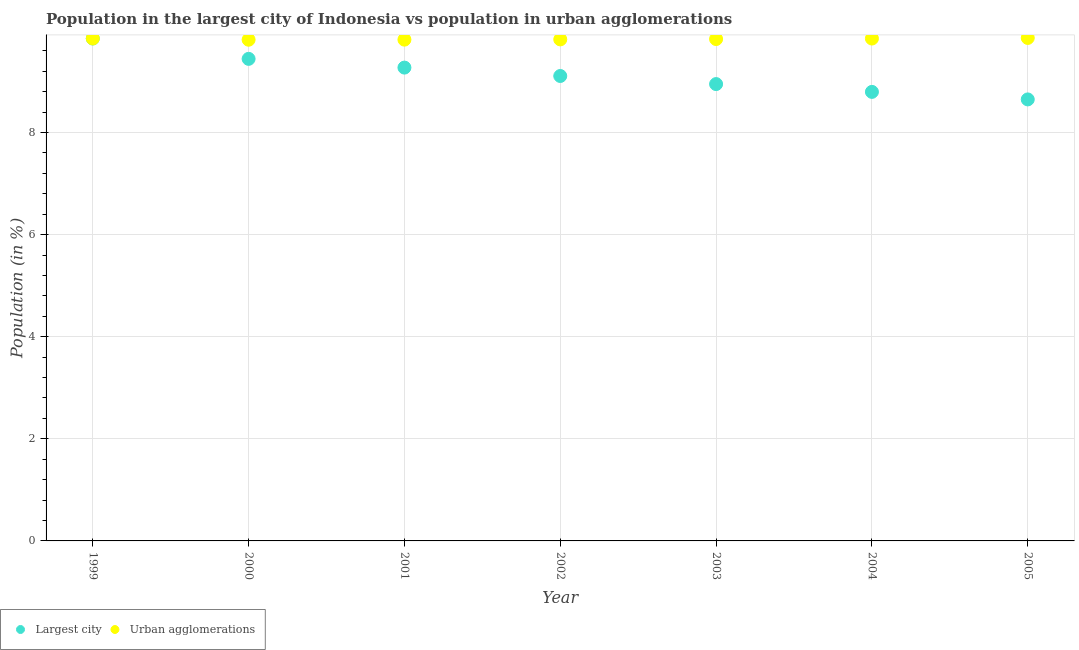What is the population in the largest city in 2003?
Provide a succinct answer. 8.95. Across all years, what is the maximum population in the largest city?
Keep it short and to the point. 9.84. Across all years, what is the minimum population in the largest city?
Keep it short and to the point. 8.65. In which year was the population in the largest city maximum?
Your response must be concise. 1999. In which year was the population in urban agglomerations minimum?
Ensure brevity in your answer.  2000. What is the total population in the largest city in the graph?
Your answer should be very brief. 64.05. What is the difference between the population in urban agglomerations in 1999 and that in 2002?
Provide a succinct answer. 0.02. What is the difference between the population in the largest city in 1999 and the population in urban agglomerations in 2004?
Provide a succinct answer. 0. What is the average population in urban agglomerations per year?
Your answer should be very brief. 9.83. In the year 2005, what is the difference between the population in the largest city and population in urban agglomerations?
Provide a short and direct response. -1.2. What is the ratio of the population in urban agglomerations in 2003 to that in 2004?
Ensure brevity in your answer.  1. Is the population in the largest city in 1999 less than that in 2003?
Your response must be concise. No. Is the difference between the population in urban agglomerations in 2000 and 2002 greater than the difference between the population in the largest city in 2000 and 2002?
Your response must be concise. No. What is the difference between the highest and the second highest population in urban agglomerations?
Ensure brevity in your answer.  0.01. What is the difference between the highest and the lowest population in the largest city?
Ensure brevity in your answer.  1.19. Is the population in the largest city strictly greater than the population in urban agglomerations over the years?
Offer a terse response. No. Is the population in the largest city strictly less than the population in urban agglomerations over the years?
Your answer should be compact. Yes. How many dotlines are there?
Your response must be concise. 2. How many years are there in the graph?
Ensure brevity in your answer.  7. Are the values on the major ticks of Y-axis written in scientific E-notation?
Offer a very short reply. No. How are the legend labels stacked?
Give a very brief answer. Horizontal. What is the title of the graph?
Ensure brevity in your answer.  Population in the largest city of Indonesia vs population in urban agglomerations. Does "% of gross capital formation" appear as one of the legend labels in the graph?
Your answer should be compact. No. What is the label or title of the X-axis?
Your response must be concise. Year. What is the Population (in %) of Largest city in 1999?
Make the answer very short. 9.84. What is the Population (in %) of Urban agglomerations in 1999?
Keep it short and to the point. 9.84. What is the Population (in %) of Largest city in 2000?
Give a very brief answer. 9.44. What is the Population (in %) in Urban agglomerations in 2000?
Make the answer very short. 9.82. What is the Population (in %) of Largest city in 2001?
Give a very brief answer. 9.27. What is the Population (in %) of Urban agglomerations in 2001?
Your response must be concise. 9.82. What is the Population (in %) of Largest city in 2002?
Make the answer very short. 9.11. What is the Population (in %) of Urban agglomerations in 2002?
Ensure brevity in your answer.  9.82. What is the Population (in %) of Largest city in 2003?
Keep it short and to the point. 8.95. What is the Population (in %) of Urban agglomerations in 2003?
Ensure brevity in your answer.  9.83. What is the Population (in %) of Largest city in 2004?
Keep it short and to the point. 8.8. What is the Population (in %) of Urban agglomerations in 2004?
Provide a succinct answer. 9.84. What is the Population (in %) in Largest city in 2005?
Your response must be concise. 8.65. What is the Population (in %) in Urban agglomerations in 2005?
Your response must be concise. 9.85. Across all years, what is the maximum Population (in %) in Largest city?
Provide a short and direct response. 9.84. Across all years, what is the maximum Population (in %) of Urban agglomerations?
Provide a succinct answer. 9.85. Across all years, what is the minimum Population (in %) of Largest city?
Make the answer very short. 8.65. Across all years, what is the minimum Population (in %) of Urban agglomerations?
Your answer should be very brief. 9.82. What is the total Population (in %) of Largest city in the graph?
Your answer should be compact. 64.05. What is the total Population (in %) of Urban agglomerations in the graph?
Your answer should be very brief. 68.83. What is the difference between the Population (in %) in Largest city in 1999 and that in 2000?
Ensure brevity in your answer.  0.4. What is the difference between the Population (in %) in Urban agglomerations in 1999 and that in 2000?
Provide a short and direct response. 0.02. What is the difference between the Population (in %) in Largest city in 1999 and that in 2001?
Your response must be concise. 0.57. What is the difference between the Population (in %) in Urban agglomerations in 1999 and that in 2001?
Keep it short and to the point. 0.02. What is the difference between the Population (in %) of Largest city in 1999 and that in 2002?
Offer a terse response. 0.73. What is the difference between the Population (in %) in Urban agglomerations in 1999 and that in 2002?
Your response must be concise. 0.02. What is the difference between the Population (in %) in Largest city in 1999 and that in 2003?
Make the answer very short. 0.89. What is the difference between the Population (in %) in Urban agglomerations in 1999 and that in 2003?
Provide a succinct answer. 0.01. What is the difference between the Population (in %) in Largest city in 1999 and that in 2004?
Offer a very short reply. 1.05. What is the difference between the Population (in %) of Urban agglomerations in 1999 and that in 2004?
Offer a terse response. 0. What is the difference between the Population (in %) in Largest city in 1999 and that in 2005?
Provide a succinct answer. 1.19. What is the difference between the Population (in %) of Urban agglomerations in 1999 and that in 2005?
Your response must be concise. -0.01. What is the difference between the Population (in %) in Largest city in 2000 and that in 2001?
Offer a very short reply. 0.17. What is the difference between the Population (in %) of Urban agglomerations in 2000 and that in 2001?
Make the answer very short. -0. What is the difference between the Population (in %) of Largest city in 2000 and that in 2002?
Your response must be concise. 0.34. What is the difference between the Population (in %) of Urban agglomerations in 2000 and that in 2002?
Offer a very short reply. -0.01. What is the difference between the Population (in %) in Largest city in 2000 and that in 2003?
Your answer should be compact. 0.49. What is the difference between the Population (in %) in Urban agglomerations in 2000 and that in 2003?
Offer a terse response. -0.01. What is the difference between the Population (in %) of Largest city in 2000 and that in 2004?
Provide a short and direct response. 0.65. What is the difference between the Population (in %) of Urban agglomerations in 2000 and that in 2004?
Make the answer very short. -0.02. What is the difference between the Population (in %) of Largest city in 2000 and that in 2005?
Your answer should be compact. 0.79. What is the difference between the Population (in %) of Urban agglomerations in 2000 and that in 2005?
Offer a terse response. -0.03. What is the difference between the Population (in %) of Largest city in 2001 and that in 2002?
Offer a very short reply. 0.16. What is the difference between the Population (in %) in Urban agglomerations in 2001 and that in 2002?
Provide a succinct answer. -0. What is the difference between the Population (in %) in Largest city in 2001 and that in 2003?
Provide a short and direct response. 0.32. What is the difference between the Population (in %) of Urban agglomerations in 2001 and that in 2003?
Your response must be concise. -0.01. What is the difference between the Population (in %) in Largest city in 2001 and that in 2004?
Your answer should be very brief. 0.48. What is the difference between the Population (in %) in Urban agglomerations in 2001 and that in 2004?
Give a very brief answer. -0.02. What is the difference between the Population (in %) of Largest city in 2001 and that in 2005?
Make the answer very short. 0.62. What is the difference between the Population (in %) of Urban agglomerations in 2001 and that in 2005?
Provide a succinct answer. -0.03. What is the difference between the Population (in %) in Largest city in 2002 and that in 2003?
Your response must be concise. 0.16. What is the difference between the Population (in %) in Urban agglomerations in 2002 and that in 2003?
Give a very brief answer. -0.01. What is the difference between the Population (in %) of Largest city in 2002 and that in 2004?
Your answer should be very brief. 0.31. What is the difference between the Population (in %) of Urban agglomerations in 2002 and that in 2004?
Offer a terse response. -0.02. What is the difference between the Population (in %) in Largest city in 2002 and that in 2005?
Ensure brevity in your answer.  0.46. What is the difference between the Population (in %) in Urban agglomerations in 2002 and that in 2005?
Provide a short and direct response. -0.03. What is the difference between the Population (in %) of Largest city in 2003 and that in 2004?
Make the answer very short. 0.15. What is the difference between the Population (in %) of Urban agglomerations in 2003 and that in 2004?
Your response must be concise. -0.01. What is the difference between the Population (in %) in Largest city in 2003 and that in 2005?
Make the answer very short. 0.3. What is the difference between the Population (in %) of Urban agglomerations in 2003 and that in 2005?
Provide a succinct answer. -0.02. What is the difference between the Population (in %) of Largest city in 2004 and that in 2005?
Your response must be concise. 0.15. What is the difference between the Population (in %) in Urban agglomerations in 2004 and that in 2005?
Your answer should be compact. -0.01. What is the difference between the Population (in %) of Largest city in 1999 and the Population (in %) of Urban agglomerations in 2000?
Offer a terse response. 0.02. What is the difference between the Population (in %) of Largest city in 1999 and the Population (in %) of Urban agglomerations in 2001?
Your answer should be very brief. 0.02. What is the difference between the Population (in %) of Largest city in 1999 and the Population (in %) of Urban agglomerations in 2002?
Ensure brevity in your answer.  0.02. What is the difference between the Population (in %) in Largest city in 1999 and the Population (in %) in Urban agglomerations in 2003?
Offer a terse response. 0.01. What is the difference between the Population (in %) in Largest city in 1999 and the Population (in %) in Urban agglomerations in 2004?
Your answer should be very brief. 0. What is the difference between the Population (in %) of Largest city in 1999 and the Population (in %) of Urban agglomerations in 2005?
Provide a short and direct response. -0.01. What is the difference between the Population (in %) of Largest city in 2000 and the Population (in %) of Urban agglomerations in 2001?
Keep it short and to the point. -0.38. What is the difference between the Population (in %) in Largest city in 2000 and the Population (in %) in Urban agglomerations in 2002?
Offer a very short reply. -0.38. What is the difference between the Population (in %) in Largest city in 2000 and the Population (in %) in Urban agglomerations in 2003?
Your answer should be very brief. -0.39. What is the difference between the Population (in %) in Largest city in 2000 and the Population (in %) in Urban agglomerations in 2004?
Your answer should be very brief. -0.4. What is the difference between the Population (in %) of Largest city in 2000 and the Population (in %) of Urban agglomerations in 2005?
Offer a terse response. -0.41. What is the difference between the Population (in %) of Largest city in 2001 and the Population (in %) of Urban agglomerations in 2002?
Provide a succinct answer. -0.55. What is the difference between the Population (in %) of Largest city in 2001 and the Population (in %) of Urban agglomerations in 2003?
Offer a very short reply. -0.56. What is the difference between the Population (in %) in Largest city in 2001 and the Population (in %) in Urban agglomerations in 2004?
Ensure brevity in your answer.  -0.57. What is the difference between the Population (in %) of Largest city in 2001 and the Population (in %) of Urban agglomerations in 2005?
Provide a succinct answer. -0.58. What is the difference between the Population (in %) of Largest city in 2002 and the Population (in %) of Urban agglomerations in 2003?
Ensure brevity in your answer.  -0.72. What is the difference between the Population (in %) of Largest city in 2002 and the Population (in %) of Urban agglomerations in 2004?
Give a very brief answer. -0.73. What is the difference between the Population (in %) of Largest city in 2002 and the Population (in %) of Urban agglomerations in 2005?
Offer a very short reply. -0.75. What is the difference between the Population (in %) in Largest city in 2003 and the Population (in %) in Urban agglomerations in 2004?
Offer a very short reply. -0.89. What is the difference between the Population (in %) in Largest city in 2003 and the Population (in %) in Urban agglomerations in 2005?
Make the answer very short. -0.9. What is the difference between the Population (in %) of Largest city in 2004 and the Population (in %) of Urban agglomerations in 2005?
Offer a terse response. -1.06. What is the average Population (in %) of Largest city per year?
Provide a short and direct response. 9.15. What is the average Population (in %) of Urban agglomerations per year?
Keep it short and to the point. 9.83. In the year 1999, what is the difference between the Population (in %) of Largest city and Population (in %) of Urban agglomerations?
Make the answer very short. -0. In the year 2000, what is the difference between the Population (in %) in Largest city and Population (in %) in Urban agglomerations?
Provide a succinct answer. -0.37. In the year 2001, what is the difference between the Population (in %) in Largest city and Population (in %) in Urban agglomerations?
Provide a succinct answer. -0.55. In the year 2002, what is the difference between the Population (in %) in Largest city and Population (in %) in Urban agglomerations?
Make the answer very short. -0.72. In the year 2003, what is the difference between the Population (in %) in Largest city and Population (in %) in Urban agglomerations?
Ensure brevity in your answer.  -0.88. In the year 2004, what is the difference between the Population (in %) in Largest city and Population (in %) in Urban agglomerations?
Provide a succinct answer. -1.04. In the year 2005, what is the difference between the Population (in %) in Largest city and Population (in %) in Urban agglomerations?
Make the answer very short. -1.2. What is the ratio of the Population (in %) of Largest city in 1999 to that in 2000?
Provide a succinct answer. 1.04. What is the ratio of the Population (in %) of Urban agglomerations in 1999 to that in 2000?
Your answer should be compact. 1. What is the ratio of the Population (in %) of Largest city in 1999 to that in 2001?
Offer a terse response. 1.06. What is the ratio of the Population (in %) of Urban agglomerations in 1999 to that in 2001?
Your response must be concise. 1. What is the ratio of the Population (in %) in Largest city in 1999 to that in 2002?
Ensure brevity in your answer.  1.08. What is the ratio of the Population (in %) in Largest city in 1999 to that in 2003?
Make the answer very short. 1.1. What is the ratio of the Population (in %) in Urban agglomerations in 1999 to that in 2003?
Provide a short and direct response. 1. What is the ratio of the Population (in %) in Largest city in 1999 to that in 2004?
Offer a terse response. 1.12. What is the ratio of the Population (in %) in Largest city in 1999 to that in 2005?
Give a very brief answer. 1.14. What is the ratio of the Population (in %) of Largest city in 2000 to that in 2001?
Your response must be concise. 1.02. What is the ratio of the Population (in %) of Urban agglomerations in 2000 to that in 2001?
Provide a succinct answer. 1. What is the ratio of the Population (in %) of Largest city in 2000 to that in 2002?
Keep it short and to the point. 1.04. What is the ratio of the Population (in %) of Largest city in 2000 to that in 2003?
Give a very brief answer. 1.06. What is the ratio of the Population (in %) in Urban agglomerations in 2000 to that in 2003?
Provide a short and direct response. 1. What is the ratio of the Population (in %) in Largest city in 2000 to that in 2004?
Your answer should be compact. 1.07. What is the ratio of the Population (in %) in Largest city in 2000 to that in 2005?
Offer a very short reply. 1.09. What is the ratio of the Population (in %) of Largest city in 2001 to that in 2002?
Make the answer very short. 1.02. What is the ratio of the Population (in %) of Urban agglomerations in 2001 to that in 2002?
Make the answer very short. 1. What is the ratio of the Population (in %) in Largest city in 2001 to that in 2003?
Provide a short and direct response. 1.04. What is the ratio of the Population (in %) of Largest city in 2001 to that in 2004?
Your response must be concise. 1.05. What is the ratio of the Population (in %) of Urban agglomerations in 2001 to that in 2004?
Make the answer very short. 1. What is the ratio of the Population (in %) in Largest city in 2001 to that in 2005?
Provide a succinct answer. 1.07. What is the ratio of the Population (in %) in Urban agglomerations in 2001 to that in 2005?
Provide a short and direct response. 1. What is the ratio of the Population (in %) of Largest city in 2002 to that in 2003?
Your answer should be very brief. 1.02. What is the ratio of the Population (in %) of Largest city in 2002 to that in 2004?
Offer a very short reply. 1.04. What is the ratio of the Population (in %) of Largest city in 2002 to that in 2005?
Provide a short and direct response. 1.05. What is the ratio of the Population (in %) in Largest city in 2003 to that in 2004?
Offer a terse response. 1.02. What is the ratio of the Population (in %) in Largest city in 2003 to that in 2005?
Offer a terse response. 1.03. What is the ratio of the Population (in %) in Largest city in 2004 to that in 2005?
Offer a terse response. 1.02. What is the difference between the highest and the second highest Population (in %) of Largest city?
Keep it short and to the point. 0.4. What is the difference between the highest and the second highest Population (in %) in Urban agglomerations?
Provide a short and direct response. 0.01. What is the difference between the highest and the lowest Population (in %) of Largest city?
Your answer should be very brief. 1.19. What is the difference between the highest and the lowest Population (in %) of Urban agglomerations?
Provide a succinct answer. 0.03. 